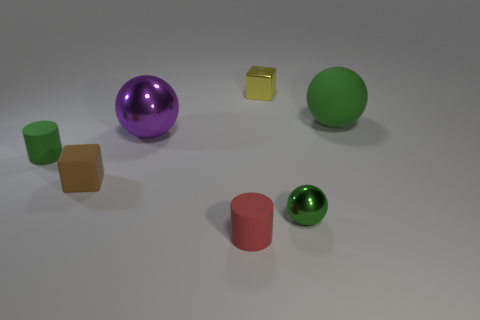Subtract all green spheres. How many spheres are left? 1 Subtract 1 balls. How many balls are left? 2 Subtract all brown balls. Subtract all blue cylinders. How many balls are left? 3 Add 2 blocks. How many objects exist? 9 Subtract all cubes. How many objects are left? 5 Subtract 0 cyan cylinders. How many objects are left? 7 Subtract all yellow things. Subtract all green rubber cylinders. How many objects are left? 5 Add 3 brown things. How many brown things are left? 4 Add 7 purple objects. How many purple objects exist? 8 